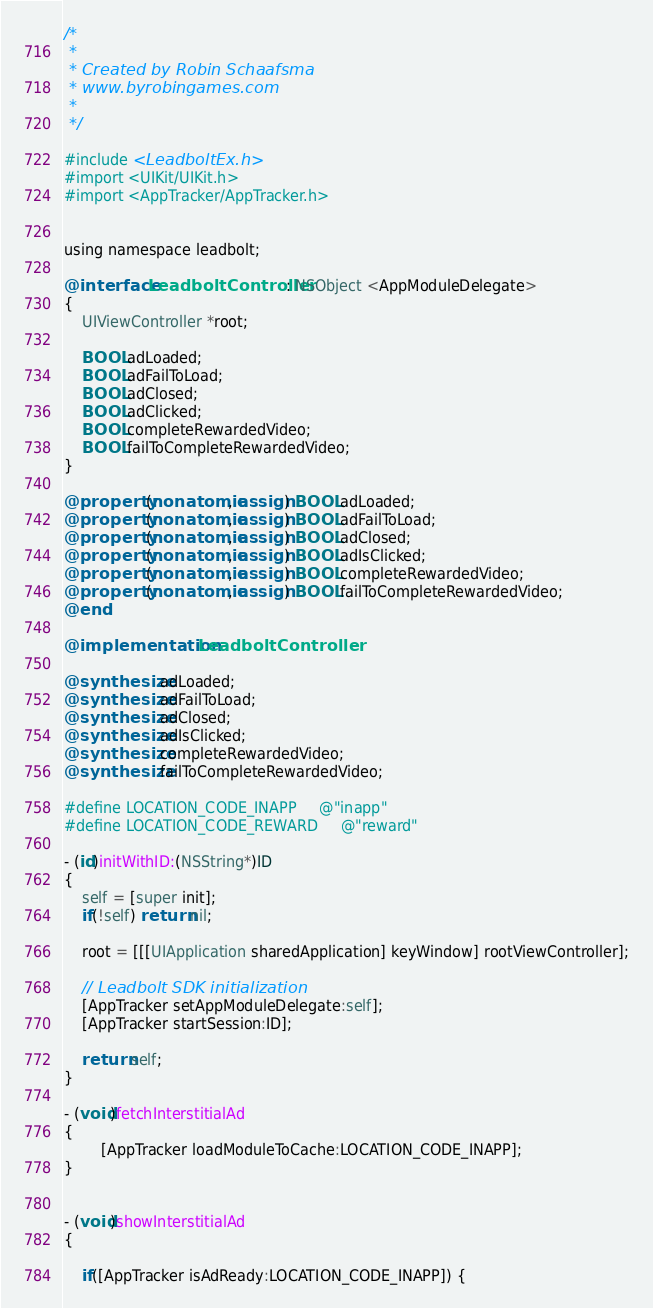<code> <loc_0><loc_0><loc_500><loc_500><_ObjectiveC_>/*
 *
 * Created by Robin Schaafsma
 * www.byrobingames.com
 *
 */

#include <LeadboltEx.h>
#import <UIKit/UIKit.h>
#import <AppTracker/AppTracker.h>


using namespace leadbolt;

@interface LeadboltController : NSObject <AppModuleDelegate>
{
    UIViewController *root;
    
    BOOL adLoaded;
    BOOL adFailToLoad;
    BOOL adClosed;
    BOOL adClicked;
    BOOL completeRewardedVideo;
    BOOL failToCompleteRewardedVideo;
}

@property (nonatomic, assign) BOOL adLoaded;
@property (nonatomic, assign) BOOL adFailToLoad;
@property (nonatomic, assign) BOOL adClosed;
@property (nonatomic, assign) BOOL adIsClicked;
@property (nonatomic, assign) BOOL completeRewardedVideo;
@property (nonatomic, assign) BOOL failToCompleteRewardedVideo;
@end

@implementation LeadboltController

@synthesize adLoaded;
@synthesize adFailToLoad;
@synthesize adClosed;
@synthesize adIsClicked;
@synthesize completeRewardedVideo;
@synthesize failToCompleteRewardedVideo;

#define LOCATION_CODE_INAPP     @"inapp"
#define LOCATION_CODE_REWARD     @"reward"

- (id)initWithID:(NSString*)ID
{
    self = [super init];
    if(!self) return nil;
    
    root = [[[UIApplication sharedApplication] keyWindow] rootViewController];
    
    // Leadbolt SDK initialization
    [AppTracker setAppModuleDelegate:self];
    [AppTracker startSession:ID];
    
    return self;
}

- (void)fetchInterstitialAd
{
        [AppTracker loadModuleToCache:LOCATION_CODE_INAPP];
}

     
- (void)showInterstitialAd
{
    
    if([AppTracker isAdReady:LOCATION_CODE_INAPP]) {</code> 